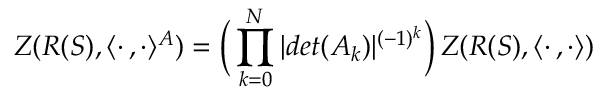Convert formula to latex. <formula><loc_0><loc_0><loc_500><loc_500>Z ( R ( S ) , \langle \cdot \, , \cdot \rangle ^ { A } ) = \left ( \, \prod _ { k = 0 } ^ { N } | d e t ( A _ { k } ) | ^ { ( - 1 ) ^ { k } } \right ) \, Z ( R ( S ) , \langle \cdot \, , \cdot \rangle )</formula> 